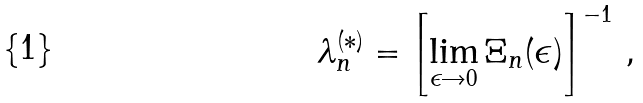Convert formula to latex. <formula><loc_0><loc_0><loc_500><loc_500>\lambda ^ { ( \ast ) } _ { n } = \left [ \lim _ { \epsilon \rightarrow 0 } \Xi _ { n } ( \epsilon ) \right ] ^ { - 1 } \, ,</formula> 